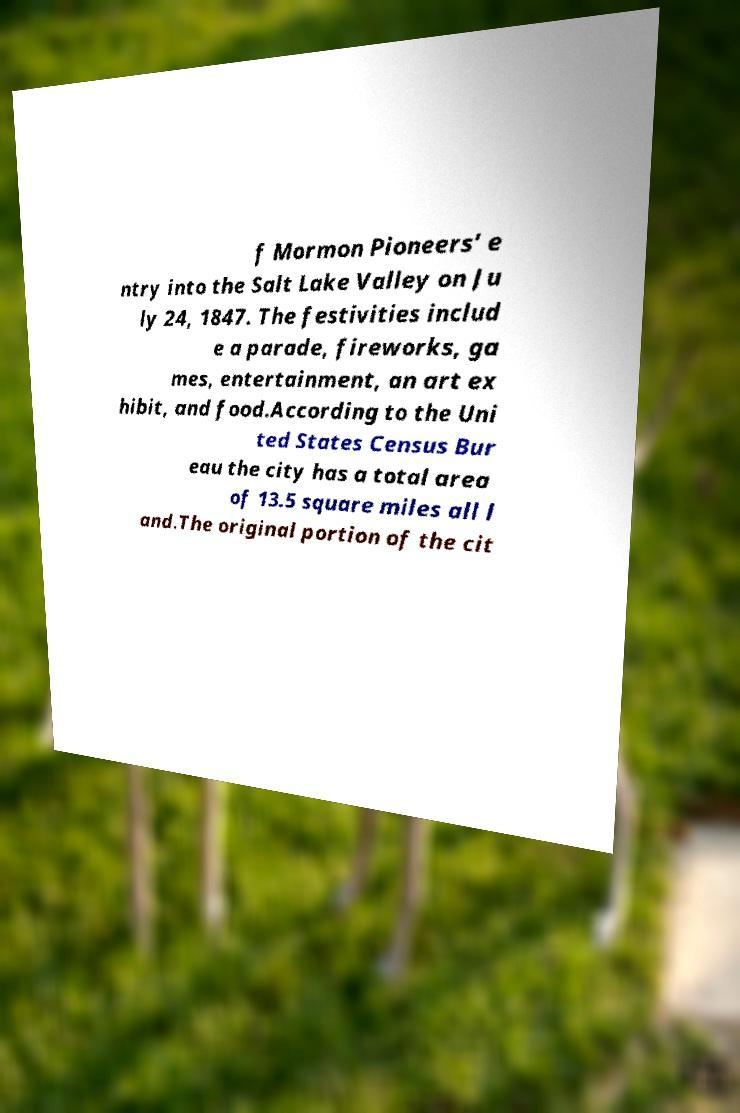What messages or text are displayed in this image? I need them in a readable, typed format. f Mormon Pioneers’ e ntry into the Salt Lake Valley on Ju ly 24, 1847. The festivities includ e a parade, fireworks, ga mes, entertainment, an art ex hibit, and food.According to the Uni ted States Census Bur eau the city has a total area of 13.5 square miles all l and.The original portion of the cit 